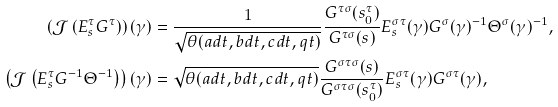<formula> <loc_0><loc_0><loc_500><loc_500>\left ( \mathcal { J } \left ( E ^ { \tau } _ { s } G ^ { \tau } \right ) \right ) ( \gamma ) & = \frac { 1 } { \sqrt { \theta ( a d t , b d t , c d t , q t ) } } \frac { G ^ { \tau \sigma } ( s _ { 0 } ^ { \tau } ) } { G ^ { \tau \sigma } ( s ) } E ^ { \sigma \tau } _ { s } ( \gamma ) G ^ { \sigma } ( \gamma ) ^ { - 1 } \Theta ^ { \sigma } ( \gamma ) ^ { - 1 } , \\ \left ( \mathcal { J } \left ( E ^ { \tau } _ { s } G ^ { - 1 } \Theta ^ { - 1 } \right ) \right ) ( \gamma ) & = \sqrt { \theta ( a d t , b d t , c d t , q t ) } \frac { G ^ { \sigma \tau \sigma } ( s ) } { G ^ { \sigma \tau \sigma } ( s _ { 0 } ^ { \tau } ) } E _ { s } ^ { \sigma \tau } ( \gamma ) G ^ { \sigma \tau } ( \gamma ) ,</formula> 